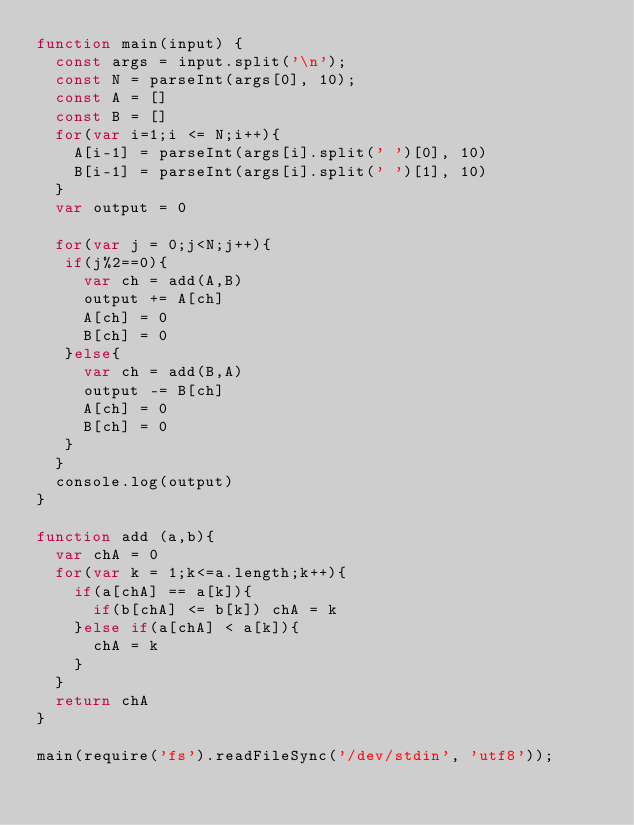<code> <loc_0><loc_0><loc_500><loc_500><_JavaScript_>function main(input) {
  const args = input.split('\n');
  const N = parseInt(args[0], 10);
  const A = []
  const B = []
  for(var i=1;i <= N;i++){
    A[i-1] = parseInt(args[i].split(' ')[0], 10)
    B[i-1] = parseInt(args[i].split(' ')[1], 10)
  }
  var output = 0
  
  for(var j = 0;j<N;j++){
   if(j%2==0){
     var ch = add(A,B)
     output += A[ch]
     A[ch] = 0
     B[ch] = 0
   }else{
     var ch = add(B,A)
     output -= B[ch]
     A[ch] = 0
     B[ch] = 0
   }
  }
  console.log(output)
}

function add (a,b){
  var chA = 0
  for(var k = 1;k<=a.length;k++){
    if(a[chA] == a[k]){
      if(b[chA] <= b[k]) chA = k
    }else if(a[chA] < a[k]){
      chA = k
    }
  }
  return chA
}

main(require('fs').readFileSync('/dev/stdin', 'utf8'));</code> 